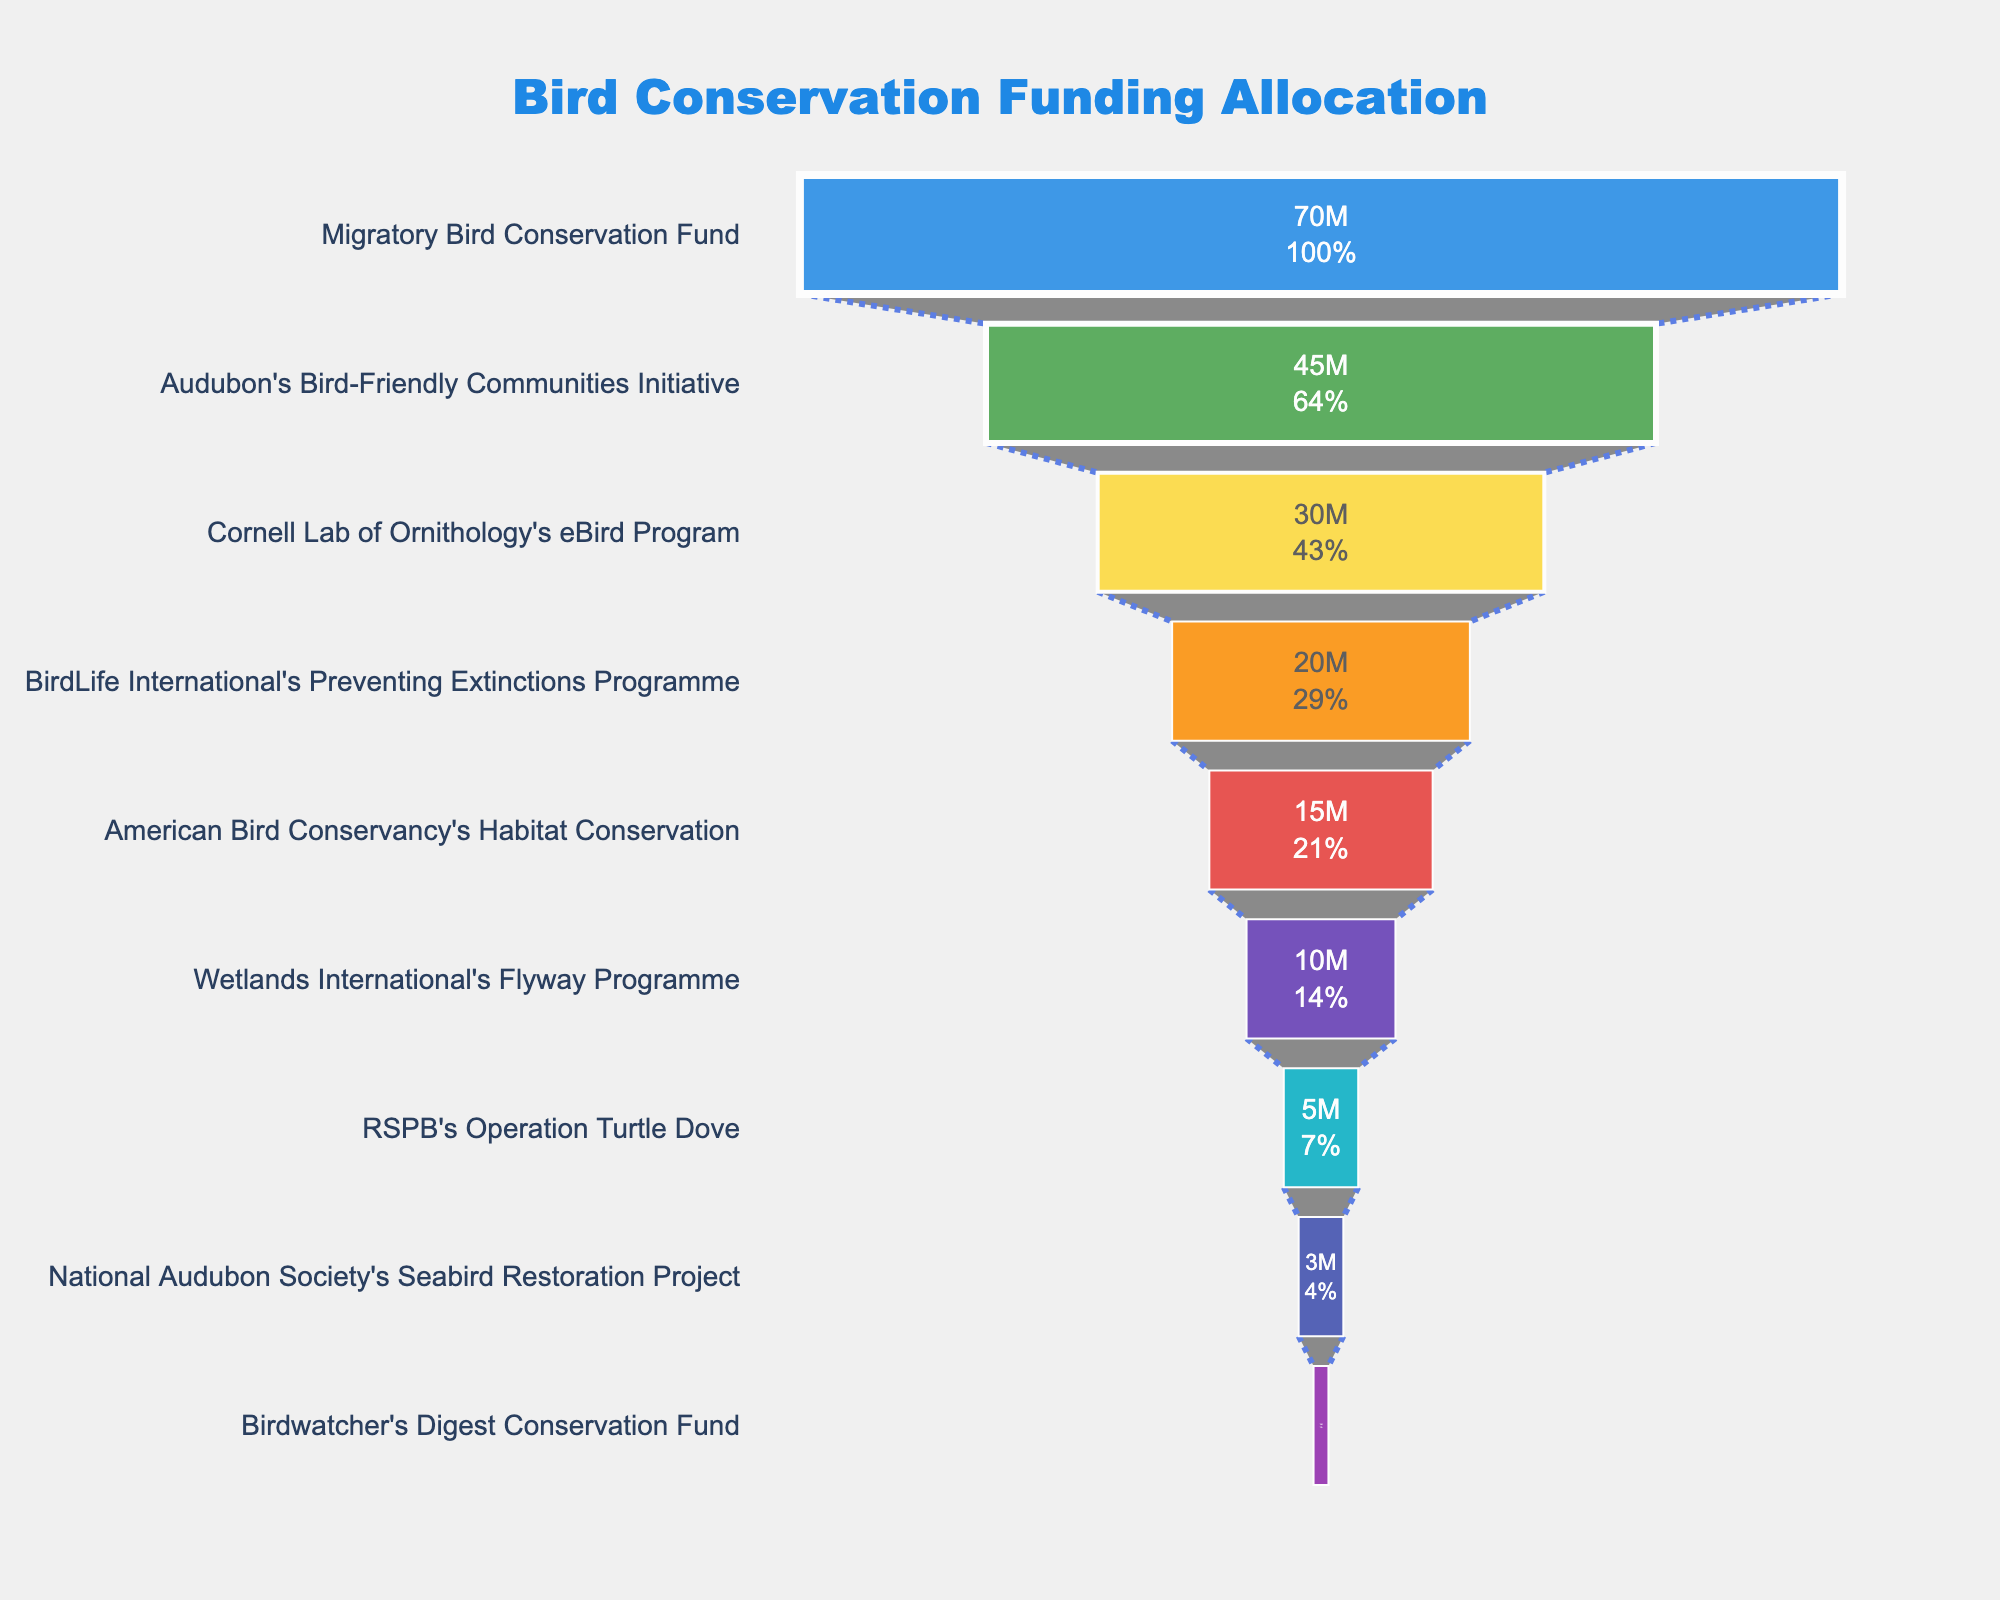What is the title of the funnel chart? The title is prominently displayed at the top of the chart in larger font size. It gives a summary of what the chart represents.
Answer: Bird Conservation Funding Allocation Which project received the highest funding allocation? The highest value at the top of the funnel, representing the largest allocation, is where Migratory Bird Conservation Fund is located. This project has a funding of $70,000,000.
Answer: Migratory Bird Conservation Fund What is the funding allocation for Wetlands International's Flyway Programme? Find the section of the funnel that corresponds to the Wetlands International's Flyway Programme and read the funding value indicated inside the segment.
Answer: $10,000,000 How much more funding does Cornell Lab of Ornithology's eBird Program receive compared to BirdLife International's Preventing Extinctions Programme? Determine the difference between the funding allocations of both projects, $30,000,000 for eBird Program and $20,000,000 for Preventing Extinctions Programme. The difference is $30,000,000 - $20,000,000.
Answer: $10,000,000 Which project received the least funding? Look at the bottom of the funnel to identify the project with the smallest segment. Birdwatcher's Digest Conservation Fund has the smallest allocation.
Answer: Birdwatcher's Digest Conservation Fund What percentage of the initial funding is allocated to Audubon's Bird-Friendly Communities Initiative? Identify the percentage value inside the segment for Audubon's initiative, which is typically labeled next to the funding value.
Answer: 31.03% What is the combined funding for American Bird Conservancy's Habitat Conservation and RSPB's Operation Turtle Dove? Add the funding amounts for both projects: $15,000,000 for Habitat Conservation and $5,000,000 for Operation Turtle Dove.
Answer: $20,000,000 How does National Audubon Society's Seabird Restoration Project compare in funding to Wetlands International's Flyway Programme? Compare the size of the segments and the corresponding funding values: $3,000,000 for Seabird Restoration and $10,000,000 for Flyway Programme. Seabird Restoration has $7,000,000 less funding.
Answer: $7,000,000 less What color is associated with the project receiving the second highest funding? Identify the color of the segment corresponding to Audubon's Bird-Friendly Communities Initiative, which is the second highest funded project. The colors are typically distinct and visually identifiable.
Answer: Green Which three projects are in the middle of the funnel in terms of funding allocation? The middle of the funnel in descending order includes the projects ranked 4th, 5th, and 6th. These are BirdLife International's Preventing Extinctions Programme, American Bird Conservancy's Habitat Conservation, and Wetlands International's Flyway Programme, respectively.
Answer: Preventing Extinctions Programme, Habitat Conservation, Flyway Programme 